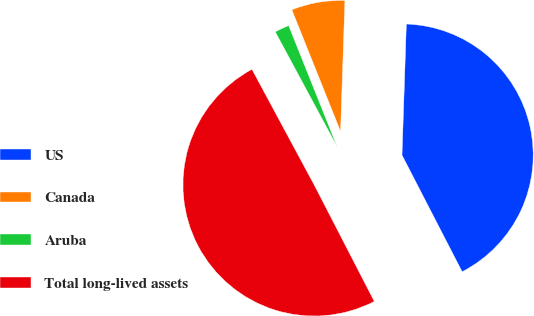Convert chart. <chart><loc_0><loc_0><loc_500><loc_500><pie_chart><fcel>US<fcel>Canada<fcel>Aruba<fcel>Total long-lived assets<nl><fcel>41.89%<fcel>6.59%<fcel>1.8%<fcel>49.72%<nl></chart> 